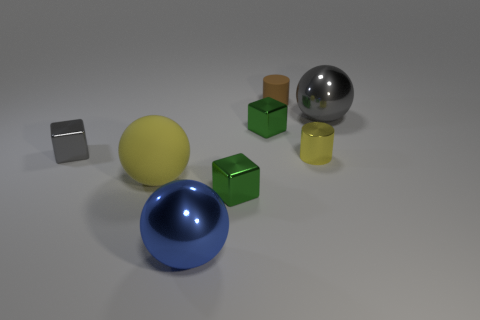Is the color of the metallic cylinder the same as the matte ball?
Your answer should be compact. Yes. Does the yellow cylinder have the same material as the gray ball?
Keep it short and to the point. Yes. What number of matte things are large gray things or big blue things?
Your answer should be very brief. 0. There is a matte object that is the same color as the tiny metal cylinder; what shape is it?
Provide a short and direct response. Sphere. There is a tiny cylinder in front of the gray sphere; is it the same color as the large rubber sphere?
Keep it short and to the point. Yes. What shape is the big metal object left of the large metallic ball on the right side of the tiny yellow cylinder?
Your answer should be very brief. Sphere. What number of objects are balls that are behind the blue object or tiny things that are behind the gray metal block?
Offer a very short reply. 4. There is a big gray thing that is the same material as the large blue ball; what shape is it?
Your answer should be very brief. Sphere. Are there any other things that have the same color as the big rubber object?
Offer a terse response. Yes. There is a large gray object that is the same shape as the yellow matte object; what is it made of?
Your response must be concise. Metal. 